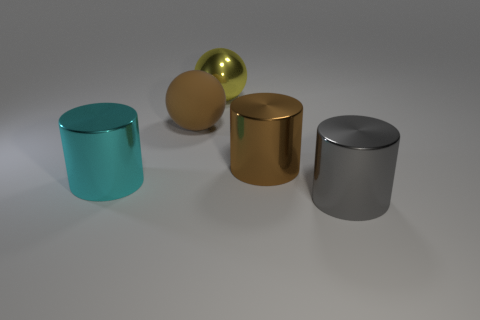What shape is the cyan thing that is the same size as the brown ball?
Your answer should be very brief. Cylinder. There is a large ball that is the same material as the gray object; what is its color?
Your response must be concise. Yellow. There is a large brown matte thing; is it the same shape as the metallic thing that is behind the brown matte thing?
Offer a very short reply. Yes. There is a large cylinder that is the same color as the large matte ball; what is it made of?
Your response must be concise. Metal. What is the material of the brown sphere that is the same size as the gray metal cylinder?
Offer a very short reply. Rubber. Are there any shiny cylinders of the same color as the matte thing?
Make the answer very short. Yes. There is a large object that is both in front of the brown metallic cylinder and right of the brown rubber thing; what shape is it?
Give a very brief answer. Cylinder. What number of small red objects have the same material as the brown cylinder?
Keep it short and to the point. 0. Are there fewer big spheres in front of the brown matte thing than brown cylinders behind the large cyan metal cylinder?
Offer a very short reply. Yes. There is a big sphere in front of the big metallic thing that is behind the large metal cylinder that is behind the cyan cylinder; what is it made of?
Keep it short and to the point. Rubber. 